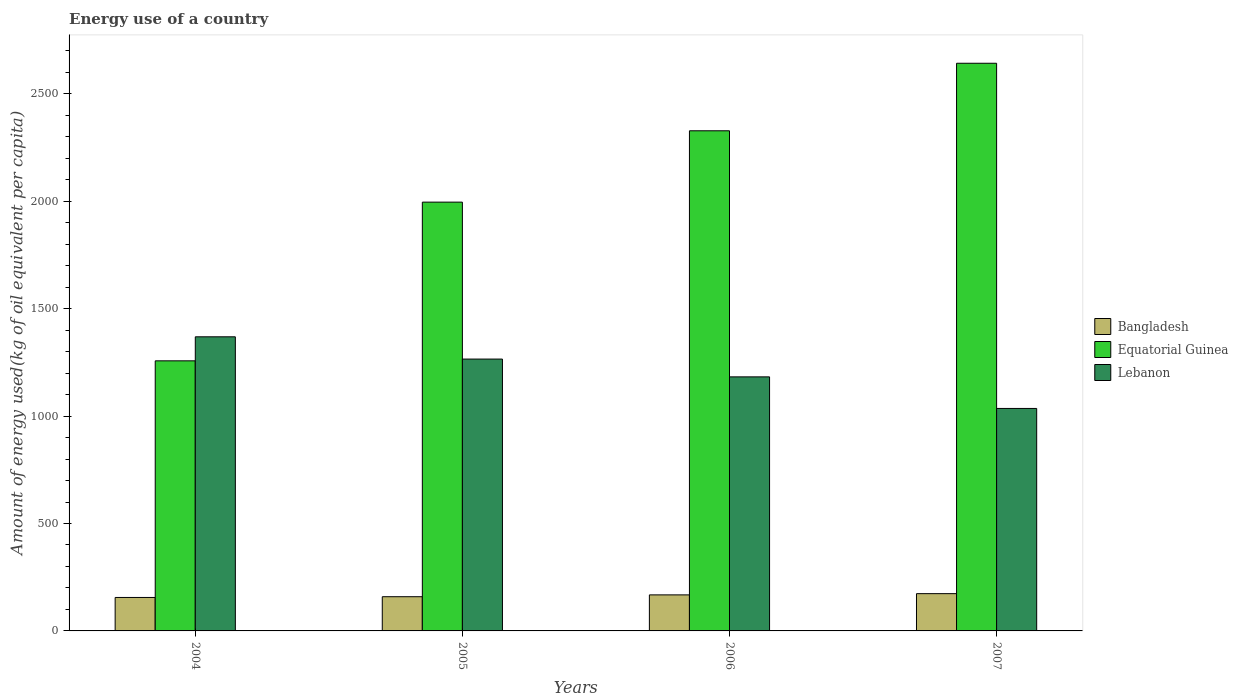How many groups of bars are there?
Provide a short and direct response. 4. Are the number of bars per tick equal to the number of legend labels?
Offer a terse response. Yes. Are the number of bars on each tick of the X-axis equal?
Your answer should be compact. Yes. How many bars are there on the 1st tick from the left?
Offer a very short reply. 3. How many bars are there on the 1st tick from the right?
Give a very brief answer. 3. What is the label of the 3rd group of bars from the left?
Provide a succinct answer. 2006. What is the amount of energy used in in Equatorial Guinea in 2007?
Provide a short and direct response. 2641.94. Across all years, what is the maximum amount of energy used in in Lebanon?
Make the answer very short. 1368.81. Across all years, what is the minimum amount of energy used in in Bangladesh?
Your answer should be compact. 155.75. What is the total amount of energy used in in Equatorial Guinea in the graph?
Offer a terse response. 8222.23. What is the difference between the amount of energy used in in Bangladesh in 2004 and that in 2006?
Your answer should be very brief. -12.01. What is the difference between the amount of energy used in in Bangladesh in 2005 and the amount of energy used in in Lebanon in 2004?
Provide a succinct answer. -1209.6. What is the average amount of energy used in in Lebanon per year?
Give a very brief answer. 1212.95. In the year 2005, what is the difference between the amount of energy used in in Bangladesh and amount of energy used in in Equatorial Guinea?
Provide a short and direct response. -1836.43. What is the ratio of the amount of energy used in in Equatorial Guinea in 2005 to that in 2006?
Offer a very short reply. 0.86. Is the amount of energy used in in Bangladesh in 2006 less than that in 2007?
Make the answer very short. Yes. What is the difference between the highest and the second highest amount of energy used in in Bangladesh?
Offer a very short reply. 5.74. What is the difference between the highest and the lowest amount of energy used in in Lebanon?
Your answer should be very brief. 333.42. In how many years, is the amount of energy used in in Bangladesh greater than the average amount of energy used in in Bangladesh taken over all years?
Provide a succinct answer. 2. What does the 2nd bar from the left in 2007 represents?
Ensure brevity in your answer.  Equatorial Guinea. What does the 2nd bar from the right in 2004 represents?
Keep it short and to the point. Equatorial Guinea. Is it the case that in every year, the sum of the amount of energy used in in Lebanon and amount of energy used in in Equatorial Guinea is greater than the amount of energy used in in Bangladesh?
Give a very brief answer. Yes. How many bars are there?
Make the answer very short. 12. Are all the bars in the graph horizontal?
Your answer should be compact. No. Does the graph contain grids?
Ensure brevity in your answer.  No. How many legend labels are there?
Offer a very short reply. 3. What is the title of the graph?
Give a very brief answer. Energy use of a country. Does "Fragile and conflict affected situations" appear as one of the legend labels in the graph?
Provide a succinct answer. No. What is the label or title of the Y-axis?
Keep it short and to the point. Amount of energy used(kg of oil equivalent per capita). What is the Amount of energy used(kg of oil equivalent per capita) of Bangladesh in 2004?
Keep it short and to the point. 155.75. What is the Amount of energy used(kg of oil equivalent per capita) of Equatorial Guinea in 2004?
Your answer should be compact. 1257.01. What is the Amount of energy used(kg of oil equivalent per capita) of Lebanon in 2004?
Give a very brief answer. 1368.81. What is the Amount of energy used(kg of oil equivalent per capita) in Bangladesh in 2005?
Make the answer very short. 159.21. What is the Amount of energy used(kg of oil equivalent per capita) of Equatorial Guinea in 2005?
Provide a short and direct response. 1995.63. What is the Amount of energy used(kg of oil equivalent per capita) in Lebanon in 2005?
Your response must be concise. 1265.23. What is the Amount of energy used(kg of oil equivalent per capita) in Bangladesh in 2006?
Your answer should be very brief. 167.75. What is the Amount of energy used(kg of oil equivalent per capita) in Equatorial Guinea in 2006?
Keep it short and to the point. 2327.64. What is the Amount of energy used(kg of oil equivalent per capita) of Lebanon in 2006?
Your response must be concise. 1182.36. What is the Amount of energy used(kg of oil equivalent per capita) in Bangladesh in 2007?
Give a very brief answer. 173.49. What is the Amount of energy used(kg of oil equivalent per capita) of Equatorial Guinea in 2007?
Offer a terse response. 2641.94. What is the Amount of energy used(kg of oil equivalent per capita) in Lebanon in 2007?
Your answer should be very brief. 1035.39. Across all years, what is the maximum Amount of energy used(kg of oil equivalent per capita) of Bangladesh?
Ensure brevity in your answer.  173.49. Across all years, what is the maximum Amount of energy used(kg of oil equivalent per capita) of Equatorial Guinea?
Your answer should be very brief. 2641.94. Across all years, what is the maximum Amount of energy used(kg of oil equivalent per capita) in Lebanon?
Your response must be concise. 1368.81. Across all years, what is the minimum Amount of energy used(kg of oil equivalent per capita) of Bangladesh?
Provide a short and direct response. 155.75. Across all years, what is the minimum Amount of energy used(kg of oil equivalent per capita) in Equatorial Guinea?
Give a very brief answer. 1257.01. Across all years, what is the minimum Amount of energy used(kg of oil equivalent per capita) of Lebanon?
Provide a succinct answer. 1035.39. What is the total Amount of energy used(kg of oil equivalent per capita) in Bangladesh in the graph?
Provide a short and direct response. 656.2. What is the total Amount of energy used(kg of oil equivalent per capita) in Equatorial Guinea in the graph?
Make the answer very short. 8222.23. What is the total Amount of energy used(kg of oil equivalent per capita) in Lebanon in the graph?
Your answer should be very brief. 4851.79. What is the difference between the Amount of energy used(kg of oil equivalent per capita) of Bangladesh in 2004 and that in 2005?
Give a very brief answer. -3.46. What is the difference between the Amount of energy used(kg of oil equivalent per capita) in Equatorial Guinea in 2004 and that in 2005?
Ensure brevity in your answer.  -738.63. What is the difference between the Amount of energy used(kg of oil equivalent per capita) in Lebanon in 2004 and that in 2005?
Your answer should be compact. 103.59. What is the difference between the Amount of energy used(kg of oil equivalent per capita) of Bangladesh in 2004 and that in 2006?
Your answer should be compact. -12.01. What is the difference between the Amount of energy used(kg of oil equivalent per capita) in Equatorial Guinea in 2004 and that in 2006?
Give a very brief answer. -1070.63. What is the difference between the Amount of energy used(kg of oil equivalent per capita) in Lebanon in 2004 and that in 2006?
Provide a succinct answer. 186.45. What is the difference between the Amount of energy used(kg of oil equivalent per capita) of Bangladesh in 2004 and that in 2007?
Provide a succinct answer. -17.74. What is the difference between the Amount of energy used(kg of oil equivalent per capita) in Equatorial Guinea in 2004 and that in 2007?
Give a very brief answer. -1384.93. What is the difference between the Amount of energy used(kg of oil equivalent per capita) of Lebanon in 2004 and that in 2007?
Offer a very short reply. 333.42. What is the difference between the Amount of energy used(kg of oil equivalent per capita) of Bangladesh in 2005 and that in 2006?
Offer a very short reply. -8.55. What is the difference between the Amount of energy used(kg of oil equivalent per capita) in Equatorial Guinea in 2005 and that in 2006?
Offer a terse response. -332.01. What is the difference between the Amount of energy used(kg of oil equivalent per capita) in Lebanon in 2005 and that in 2006?
Provide a succinct answer. 82.86. What is the difference between the Amount of energy used(kg of oil equivalent per capita) in Bangladesh in 2005 and that in 2007?
Ensure brevity in your answer.  -14.28. What is the difference between the Amount of energy used(kg of oil equivalent per capita) of Equatorial Guinea in 2005 and that in 2007?
Keep it short and to the point. -646.31. What is the difference between the Amount of energy used(kg of oil equivalent per capita) of Lebanon in 2005 and that in 2007?
Your response must be concise. 229.83. What is the difference between the Amount of energy used(kg of oil equivalent per capita) in Bangladesh in 2006 and that in 2007?
Give a very brief answer. -5.74. What is the difference between the Amount of energy used(kg of oil equivalent per capita) of Equatorial Guinea in 2006 and that in 2007?
Your response must be concise. -314.3. What is the difference between the Amount of energy used(kg of oil equivalent per capita) of Lebanon in 2006 and that in 2007?
Offer a terse response. 146.97. What is the difference between the Amount of energy used(kg of oil equivalent per capita) in Bangladesh in 2004 and the Amount of energy used(kg of oil equivalent per capita) in Equatorial Guinea in 2005?
Provide a succinct answer. -1839.89. What is the difference between the Amount of energy used(kg of oil equivalent per capita) in Bangladesh in 2004 and the Amount of energy used(kg of oil equivalent per capita) in Lebanon in 2005?
Your answer should be compact. -1109.48. What is the difference between the Amount of energy used(kg of oil equivalent per capita) of Equatorial Guinea in 2004 and the Amount of energy used(kg of oil equivalent per capita) of Lebanon in 2005?
Your answer should be compact. -8.22. What is the difference between the Amount of energy used(kg of oil equivalent per capita) in Bangladesh in 2004 and the Amount of energy used(kg of oil equivalent per capita) in Equatorial Guinea in 2006?
Give a very brief answer. -2171.89. What is the difference between the Amount of energy used(kg of oil equivalent per capita) of Bangladesh in 2004 and the Amount of energy used(kg of oil equivalent per capita) of Lebanon in 2006?
Keep it short and to the point. -1026.61. What is the difference between the Amount of energy used(kg of oil equivalent per capita) in Equatorial Guinea in 2004 and the Amount of energy used(kg of oil equivalent per capita) in Lebanon in 2006?
Keep it short and to the point. 74.65. What is the difference between the Amount of energy used(kg of oil equivalent per capita) in Bangladesh in 2004 and the Amount of energy used(kg of oil equivalent per capita) in Equatorial Guinea in 2007?
Offer a very short reply. -2486.19. What is the difference between the Amount of energy used(kg of oil equivalent per capita) of Bangladesh in 2004 and the Amount of energy used(kg of oil equivalent per capita) of Lebanon in 2007?
Provide a short and direct response. -879.64. What is the difference between the Amount of energy used(kg of oil equivalent per capita) of Equatorial Guinea in 2004 and the Amount of energy used(kg of oil equivalent per capita) of Lebanon in 2007?
Provide a short and direct response. 221.62. What is the difference between the Amount of energy used(kg of oil equivalent per capita) in Bangladesh in 2005 and the Amount of energy used(kg of oil equivalent per capita) in Equatorial Guinea in 2006?
Ensure brevity in your answer.  -2168.43. What is the difference between the Amount of energy used(kg of oil equivalent per capita) of Bangladesh in 2005 and the Amount of energy used(kg of oil equivalent per capita) of Lebanon in 2006?
Give a very brief answer. -1023.15. What is the difference between the Amount of energy used(kg of oil equivalent per capita) of Equatorial Guinea in 2005 and the Amount of energy used(kg of oil equivalent per capita) of Lebanon in 2006?
Offer a very short reply. 813.27. What is the difference between the Amount of energy used(kg of oil equivalent per capita) in Bangladesh in 2005 and the Amount of energy used(kg of oil equivalent per capita) in Equatorial Guinea in 2007?
Your answer should be compact. -2482.73. What is the difference between the Amount of energy used(kg of oil equivalent per capita) in Bangladesh in 2005 and the Amount of energy used(kg of oil equivalent per capita) in Lebanon in 2007?
Offer a terse response. -876.18. What is the difference between the Amount of energy used(kg of oil equivalent per capita) of Equatorial Guinea in 2005 and the Amount of energy used(kg of oil equivalent per capita) of Lebanon in 2007?
Offer a very short reply. 960.24. What is the difference between the Amount of energy used(kg of oil equivalent per capita) in Bangladesh in 2006 and the Amount of energy used(kg of oil equivalent per capita) in Equatorial Guinea in 2007?
Offer a terse response. -2474.19. What is the difference between the Amount of energy used(kg of oil equivalent per capita) of Bangladesh in 2006 and the Amount of energy used(kg of oil equivalent per capita) of Lebanon in 2007?
Offer a terse response. -867.64. What is the difference between the Amount of energy used(kg of oil equivalent per capita) of Equatorial Guinea in 2006 and the Amount of energy used(kg of oil equivalent per capita) of Lebanon in 2007?
Provide a succinct answer. 1292.25. What is the average Amount of energy used(kg of oil equivalent per capita) in Bangladesh per year?
Give a very brief answer. 164.05. What is the average Amount of energy used(kg of oil equivalent per capita) of Equatorial Guinea per year?
Your answer should be very brief. 2055.56. What is the average Amount of energy used(kg of oil equivalent per capita) of Lebanon per year?
Offer a terse response. 1212.95. In the year 2004, what is the difference between the Amount of energy used(kg of oil equivalent per capita) of Bangladesh and Amount of energy used(kg of oil equivalent per capita) of Equatorial Guinea?
Make the answer very short. -1101.26. In the year 2004, what is the difference between the Amount of energy used(kg of oil equivalent per capita) in Bangladesh and Amount of energy used(kg of oil equivalent per capita) in Lebanon?
Offer a very short reply. -1213.06. In the year 2004, what is the difference between the Amount of energy used(kg of oil equivalent per capita) of Equatorial Guinea and Amount of energy used(kg of oil equivalent per capita) of Lebanon?
Ensure brevity in your answer.  -111.8. In the year 2005, what is the difference between the Amount of energy used(kg of oil equivalent per capita) of Bangladesh and Amount of energy used(kg of oil equivalent per capita) of Equatorial Guinea?
Make the answer very short. -1836.43. In the year 2005, what is the difference between the Amount of energy used(kg of oil equivalent per capita) of Bangladesh and Amount of energy used(kg of oil equivalent per capita) of Lebanon?
Provide a short and direct response. -1106.02. In the year 2005, what is the difference between the Amount of energy used(kg of oil equivalent per capita) in Equatorial Guinea and Amount of energy used(kg of oil equivalent per capita) in Lebanon?
Keep it short and to the point. 730.41. In the year 2006, what is the difference between the Amount of energy used(kg of oil equivalent per capita) in Bangladesh and Amount of energy used(kg of oil equivalent per capita) in Equatorial Guinea?
Offer a terse response. -2159.89. In the year 2006, what is the difference between the Amount of energy used(kg of oil equivalent per capita) of Bangladesh and Amount of energy used(kg of oil equivalent per capita) of Lebanon?
Ensure brevity in your answer.  -1014.61. In the year 2006, what is the difference between the Amount of energy used(kg of oil equivalent per capita) in Equatorial Guinea and Amount of energy used(kg of oil equivalent per capita) in Lebanon?
Your answer should be compact. 1145.28. In the year 2007, what is the difference between the Amount of energy used(kg of oil equivalent per capita) of Bangladesh and Amount of energy used(kg of oil equivalent per capita) of Equatorial Guinea?
Your answer should be very brief. -2468.45. In the year 2007, what is the difference between the Amount of energy used(kg of oil equivalent per capita) of Bangladesh and Amount of energy used(kg of oil equivalent per capita) of Lebanon?
Your answer should be compact. -861.9. In the year 2007, what is the difference between the Amount of energy used(kg of oil equivalent per capita) of Equatorial Guinea and Amount of energy used(kg of oil equivalent per capita) of Lebanon?
Your answer should be compact. 1606.55. What is the ratio of the Amount of energy used(kg of oil equivalent per capita) of Bangladesh in 2004 to that in 2005?
Your response must be concise. 0.98. What is the ratio of the Amount of energy used(kg of oil equivalent per capita) of Equatorial Guinea in 2004 to that in 2005?
Your answer should be compact. 0.63. What is the ratio of the Amount of energy used(kg of oil equivalent per capita) in Lebanon in 2004 to that in 2005?
Keep it short and to the point. 1.08. What is the ratio of the Amount of energy used(kg of oil equivalent per capita) of Bangladesh in 2004 to that in 2006?
Your response must be concise. 0.93. What is the ratio of the Amount of energy used(kg of oil equivalent per capita) in Equatorial Guinea in 2004 to that in 2006?
Keep it short and to the point. 0.54. What is the ratio of the Amount of energy used(kg of oil equivalent per capita) in Lebanon in 2004 to that in 2006?
Keep it short and to the point. 1.16. What is the ratio of the Amount of energy used(kg of oil equivalent per capita) of Bangladesh in 2004 to that in 2007?
Provide a succinct answer. 0.9. What is the ratio of the Amount of energy used(kg of oil equivalent per capita) in Equatorial Guinea in 2004 to that in 2007?
Your answer should be compact. 0.48. What is the ratio of the Amount of energy used(kg of oil equivalent per capita) in Lebanon in 2004 to that in 2007?
Offer a very short reply. 1.32. What is the ratio of the Amount of energy used(kg of oil equivalent per capita) in Bangladesh in 2005 to that in 2006?
Offer a very short reply. 0.95. What is the ratio of the Amount of energy used(kg of oil equivalent per capita) of Equatorial Guinea in 2005 to that in 2006?
Provide a succinct answer. 0.86. What is the ratio of the Amount of energy used(kg of oil equivalent per capita) in Lebanon in 2005 to that in 2006?
Offer a very short reply. 1.07. What is the ratio of the Amount of energy used(kg of oil equivalent per capita) of Bangladesh in 2005 to that in 2007?
Keep it short and to the point. 0.92. What is the ratio of the Amount of energy used(kg of oil equivalent per capita) in Equatorial Guinea in 2005 to that in 2007?
Your response must be concise. 0.76. What is the ratio of the Amount of energy used(kg of oil equivalent per capita) of Lebanon in 2005 to that in 2007?
Your answer should be compact. 1.22. What is the ratio of the Amount of energy used(kg of oil equivalent per capita) of Bangladesh in 2006 to that in 2007?
Keep it short and to the point. 0.97. What is the ratio of the Amount of energy used(kg of oil equivalent per capita) in Equatorial Guinea in 2006 to that in 2007?
Provide a short and direct response. 0.88. What is the ratio of the Amount of energy used(kg of oil equivalent per capita) of Lebanon in 2006 to that in 2007?
Your answer should be compact. 1.14. What is the difference between the highest and the second highest Amount of energy used(kg of oil equivalent per capita) of Bangladesh?
Keep it short and to the point. 5.74. What is the difference between the highest and the second highest Amount of energy used(kg of oil equivalent per capita) of Equatorial Guinea?
Your response must be concise. 314.3. What is the difference between the highest and the second highest Amount of energy used(kg of oil equivalent per capita) of Lebanon?
Your response must be concise. 103.59. What is the difference between the highest and the lowest Amount of energy used(kg of oil equivalent per capita) of Bangladesh?
Your answer should be compact. 17.74. What is the difference between the highest and the lowest Amount of energy used(kg of oil equivalent per capita) of Equatorial Guinea?
Keep it short and to the point. 1384.93. What is the difference between the highest and the lowest Amount of energy used(kg of oil equivalent per capita) in Lebanon?
Your response must be concise. 333.42. 